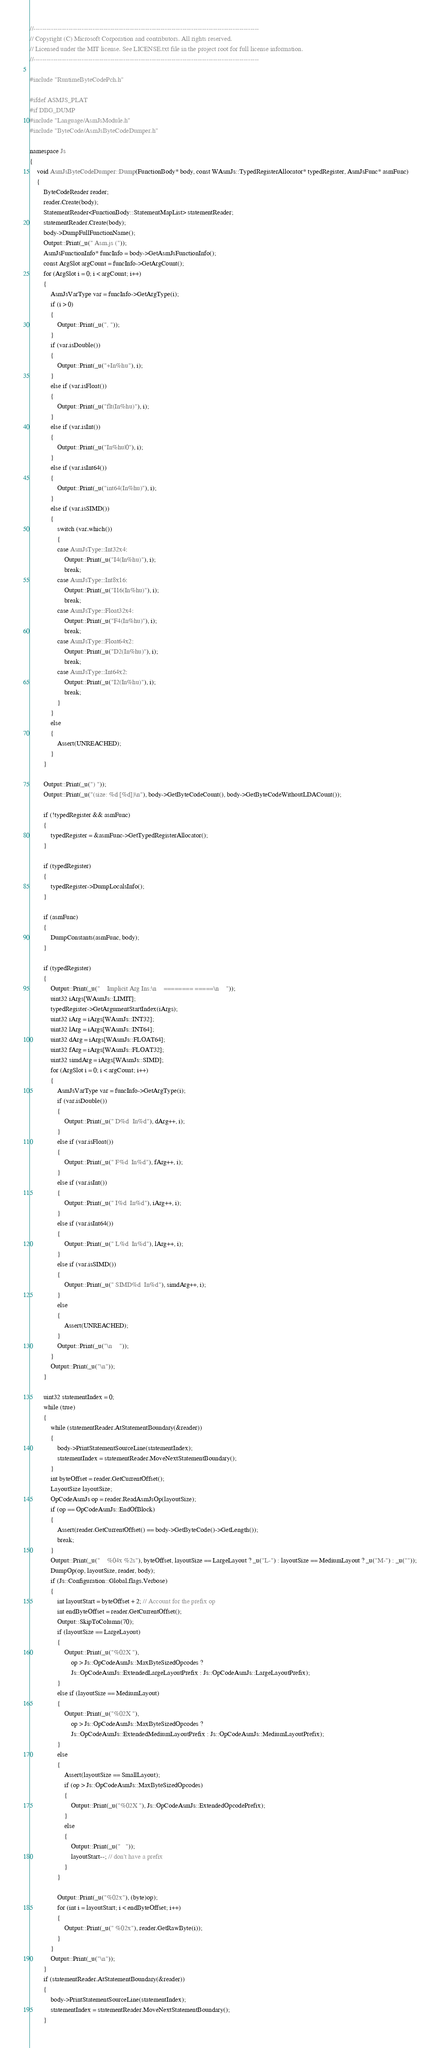<code> <loc_0><loc_0><loc_500><loc_500><_C++_>//-------------------------------------------------------------------------------------------------------
// Copyright (C) Microsoft Corporation and contributors. All rights reserved.
// Licensed under the MIT license. See LICENSE.txt file in the project root for full license information.
//-------------------------------------------------------------------------------------------------------

#include "RuntimeByteCodePch.h"

#ifdef ASMJS_PLAT
#if DBG_DUMP
#include "Language/AsmJsModule.h"
#include "ByteCode/AsmJsByteCodeDumper.h"

namespace Js
{
    void AsmJsByteCodeDumper::Dump(FunctionBody* body, const WAsmJs::TypedRegisterAllocator* typedRegister, AsmJsFunc* asmFunc)
    {
        ByteCodeReader reader;
        reader.Create(body);
        StatementReader<FunctionBody::StatementMapList> statementReader;
        statementReader.Create(body);
        body->DumpFullFunctionName();
        Output::Print(_u(" Asm.js ("));
        AsmJsFunctionInfo* funcInfo = body->GetAsmJsFunctionInfo();
        const ArgSlot argCount = funcInfo->GetArgCount();
        for (ArgSlot i = 0; i < argCount; i++)
        {
            AsmJsVarType var = funcInfo->GetArgType(i);
            if (i > 0)
            {
                Output::Print(_u(", "));
            }
            if (var.isDouble())
            {
                Output::Print(_u("+In%hu"), i);
            }
            else if (var.isFloat())
            {
                Output::Print(_u("flt(In%hu)"), i);
            }
            else if (var.isInt())
            {
                Output::Print(_u("In%hu|0"), i);
            }
            else if (var.isInt64())
            {
                Output::Print(_u("int64(In%hu)"), i);
            }
            else if (var.isSIMD())
            {
                switch (var.which())
                {
                case AsmJsType::Int32x4:
                    Output::Print(_u("I4(In%hu)"), i);
                    break;
                case AsmJsType::Int8x16:
                    Output::Print(_u("I16(In%hu)"), i);
                    break;
                case AsmJsType::Float32x4:
                    Output::Print(_u("F4(In%hu)"), i);
                    break;
                case AsmJsType::Float64x2:
                    Output::Print(_u("D2(In%hu)"), i);
                    break;
                case AsmJsType::Int64x2:
                    Output::Print(_u("I2(In%hu)"), i);
                    break;
                }
            }
            else
            {
                Assert(UNREACHED);
            }
        }

        Output::Print(_u(") "));
        Output::Print(_u("(size: %d [%d])\n"), body->GetByteCodeCount(), body->GetByteCodeWithoutLDACount());

        if (!typedRegister && asmFunc)
        {
            typedRegister = &asmFunc->GetTypedRegisterAllocator();
        }

        if (typedRegister)
        {
            typedRegister->DumpLocalsInfo();
        }

        if (asmFunc)
        {
            DumpConstants(asmFunc, body);
        }

        if (typedRegister)
        {
            Output::Print(_u("    Implicit Arg Ins:\n    ======== =====\n    "));
            uint32 iArgs[WAsmJs::LIMIT];
            typedRegister->GetArgumentStartIndex(iArgs);
            uint32 iArg = iArgs[WAsmJs::INT32];
            uint32 lArg = iArgs[WAsmJs::INT64];
            uint32 dArg = iArgs[WAsmJs::FLOAT64];
            uint32 fArg = iArgs[WAsmJs::FLOAT32];
            uint32 simdArg = iArgs[WAsmJs::SIMD];
            for (ArgSlot i = 0; i < argCount; i++)
            {
                AsmJsVarType var = funcInfo->GetArgType(i);
                if (var.isDouble())
                {
                    Output::Print(_u(" D%d  In%d"), dArg++, i);
                }
                else if (var.isFloat())
                {
                    Output::Print(_u(" F%d  In%d"), fArg++, i);
                }
                else if (var.isInt())
                {
                    Output::Print(_u(" I%d  In%d"), iArg++, i);
                }
                else if (var.isInt64())
                {
                    Output::Print(_u(" L%d  In%d"), lArg++, i);
                }
                else if (var.isSIMD())
                {
                    Output::Print(_u(" SIMD%d  In%d"), simdArg++, i);
                }
                else
                {
                    Assert(UNREACHED);
                }
                Output::Print(_u("\n    "));
            }
            Output::Print(_u("\n"));
        }

        uint32 statementIndex = 0;
        while (true)
        {
            while (statementReader.AtStatementBoundary(&reader))
            {
                body->PrintStatementSourceLine(statementIndex);
                statementIndex = statementReader.MoveNextStatementBoundary();
            }
            int byteOffset = reader.GetCurrentOffset();
            LayoutSize layoutSize;
            OpCodeAsmJs op = reader.ReadAsmJsOp(layoutSize);
            if (op == OpCodeAsmJs::EndOfBlock)
            {
                Assert(reader.GetCurrentOffset() == body->GetByteCode()->GetLength());
                break;
            }
            Output::Print(_u("    %04x %2s"), byteOffset, layoutSize == LargeLayout ? _u("L-") : layoutSize == MediumLayout ? _u("M-") : _u(""));
            DumpOp(op, layoutSize, reader, body);
            if (Js::Configuration::Global.flags.Verbose)
            {
                int layoutStart = byteOffset + 2; // Account for the prefix op
                int endByteOffset = reader.GetCurrentOffset();
                Output::SkipToColumn(70);
                if (layoutSize == LargeLayout)
                {
                    Output::Print(_u("%02X "),
                        op > Js::OpCodeAsmJs::MaxByteSizedOpcodes ?
                        Js::OpCodeAsmJs::ExtendedLargeLayoutPrefix : Js::OpCodeAsmJs::LargeLayoutPrefix);
                }
                else if (layoutSize == MediumLayout)
                {
                    Output::Print(_u("%02X "),
                        op > Js::OpCodeAsmJs::MaxByteSizedOpcodes ?
                        Js::OpCodeAsmJs::ExtendedMediumLayoutPrefix : Js::OpCodeAsmJs::MediumLayoutPrefix);
                }
                else
                {
                    Assert(layoutSize == SmallLayout);
                    if (op > Js::OpCodeAsmJs::MaxByteSizedOpcodes)
                    {
                        Output::Print(_u("%02X "), Js::OpCodeAsmJs::ExtendedOpcodePrefix);
                    }
                    else
                    {
                        Output::Print(_u("   "));
                        layoutStart--; // don't have a prefix
                    }
                }

                Output::Print(_u("%02x"), (byte)op);
                for (int i = layoutStart; i < endByteOffset; i++)
                {
                    Output::Print(_u(" %02x"), reader.GetRawByte(i));
                }
            }
            Output::Print(_u("\n"));
        }
        if (statementReader.AtStatementBoundary(&reader))
        {
            body->PrintStatementSourceLine(statementIndex);
            statementIndex = statementReader.MoveNextStatementBoundary();
        }</code> 